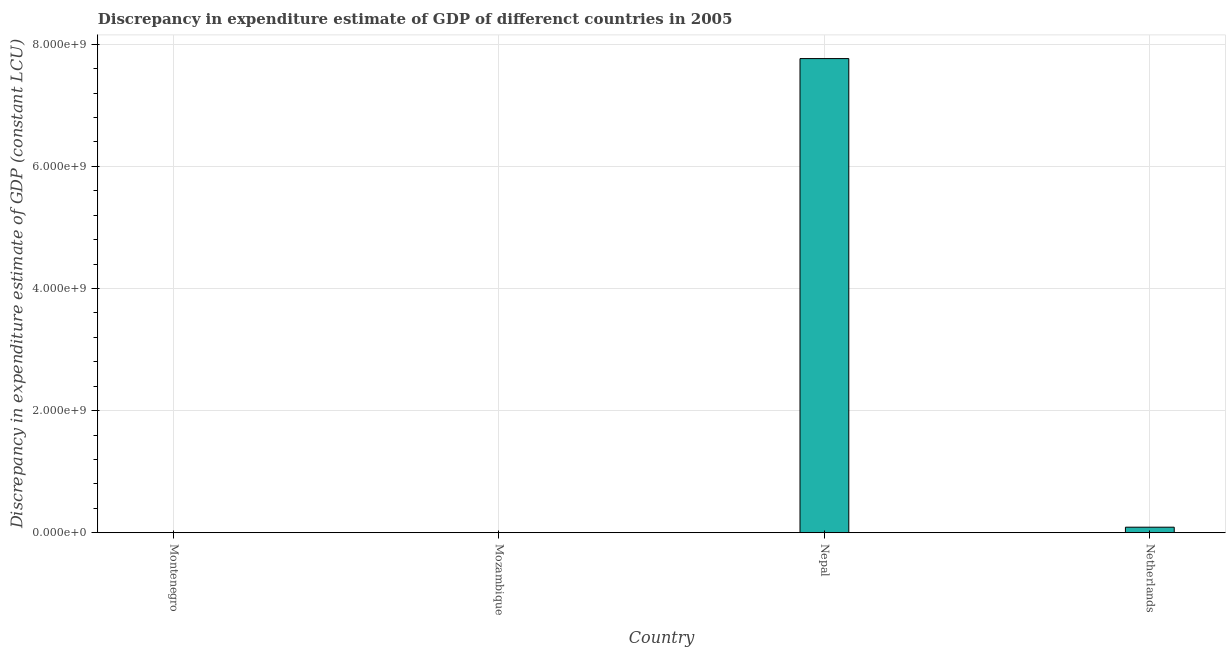Does the graph contain grids?
Give a very brief answer. Yes. What is the title of the graph?
Your answer should be compact. Discrepancy in expenditure estimate of GDP of differenct countries in 2005. What is the label or title of the X-axis?
Your answer should be very brief. Country. What is the label or title of the Y-axis?
Your response must be concise. Discrepancy in expenditure estimate of GDP (constant LCU). What is the discrepancy in expenditure estimate of gdp in Mozambique?
Your response must be concise. 0. Across all countries, what is the maximum discrepancy in expenditure estimate of gdp?
Your answer should be compact. 7.77e+09. Across all countries, what is the minimum discrepancy in expenditure estimate of gdp?
Your answer should be compact. 0. In which country was the discrepancy in expenditure estimate of gdp maximum?
Give a very brief answer. Nepal. What is the sum of the discrepancy in expenditure estimate of gdp?
Provide a succinct answer. 7.86e+09. What is the difference between the discrepancy in expenditure estimate of gdp in Nepal and Netherlands?
Give a very brief answer. 7.67e+09. What is the average discrepancy in expenditure estimate of gdp per country?
Keep it short and to the point. 1.96e+09. What is the median discrepancy in expenditure estimate of gdp?
Make the answer very short. 4.52e+07. In how many countries, is the discrepancy in expenditure estimate of gdp greater than 5600000000 LCU?
Make the answer very short. 1. Is the discrepancy in expenditure estimate of gdp in Nepal less than that in Netherlands?
Give a very brief answer. No. Is the difference between the discrepancy in expenditure estimate of gdp in Nepal and Netherlands greater than the difference between any two countries?
Your answer should be compact. No. What is the difference between the highest and the lowest discrepancy in expenditure estimate of gdp?
Your answer should be compact. 7.77e+09. In how many countries, is the discrepancy in expenditure estimate of gdp greater than the average discrepancy in expenditure estimate of gdp taken over all countries?
Offer a terse response. 1. Are the values on the major ticks of Y-axis written in scientific E-notation?
Provide a succinct answer. Yes. What is the Discrepancy in expenditure estimate of GDP (constant LCU) of Montenegro?
Offer a terse response. 0. What is the Discrepancy in expenditure estimate of GDP (constant LCU) in Nepal?
Keep it short and to the point. 7.77e+09. What is the Discrepancy in expenditure estimate of GDP (constant LCU) of Netherlands?
Ensure brevity in your answer.  9.04e+07. What is the difference between the Discrepancy in expenditure estimate of GDP (constant LCU) in Nepal and Netherlands?
Offer a very short reply. 7.67e+09. What is the ratio of the Discrepancy in expenditure estimate of GDP (constant LCU) in Nepal to that in Netherlands?
Keep it short and to the point. 85.87. 